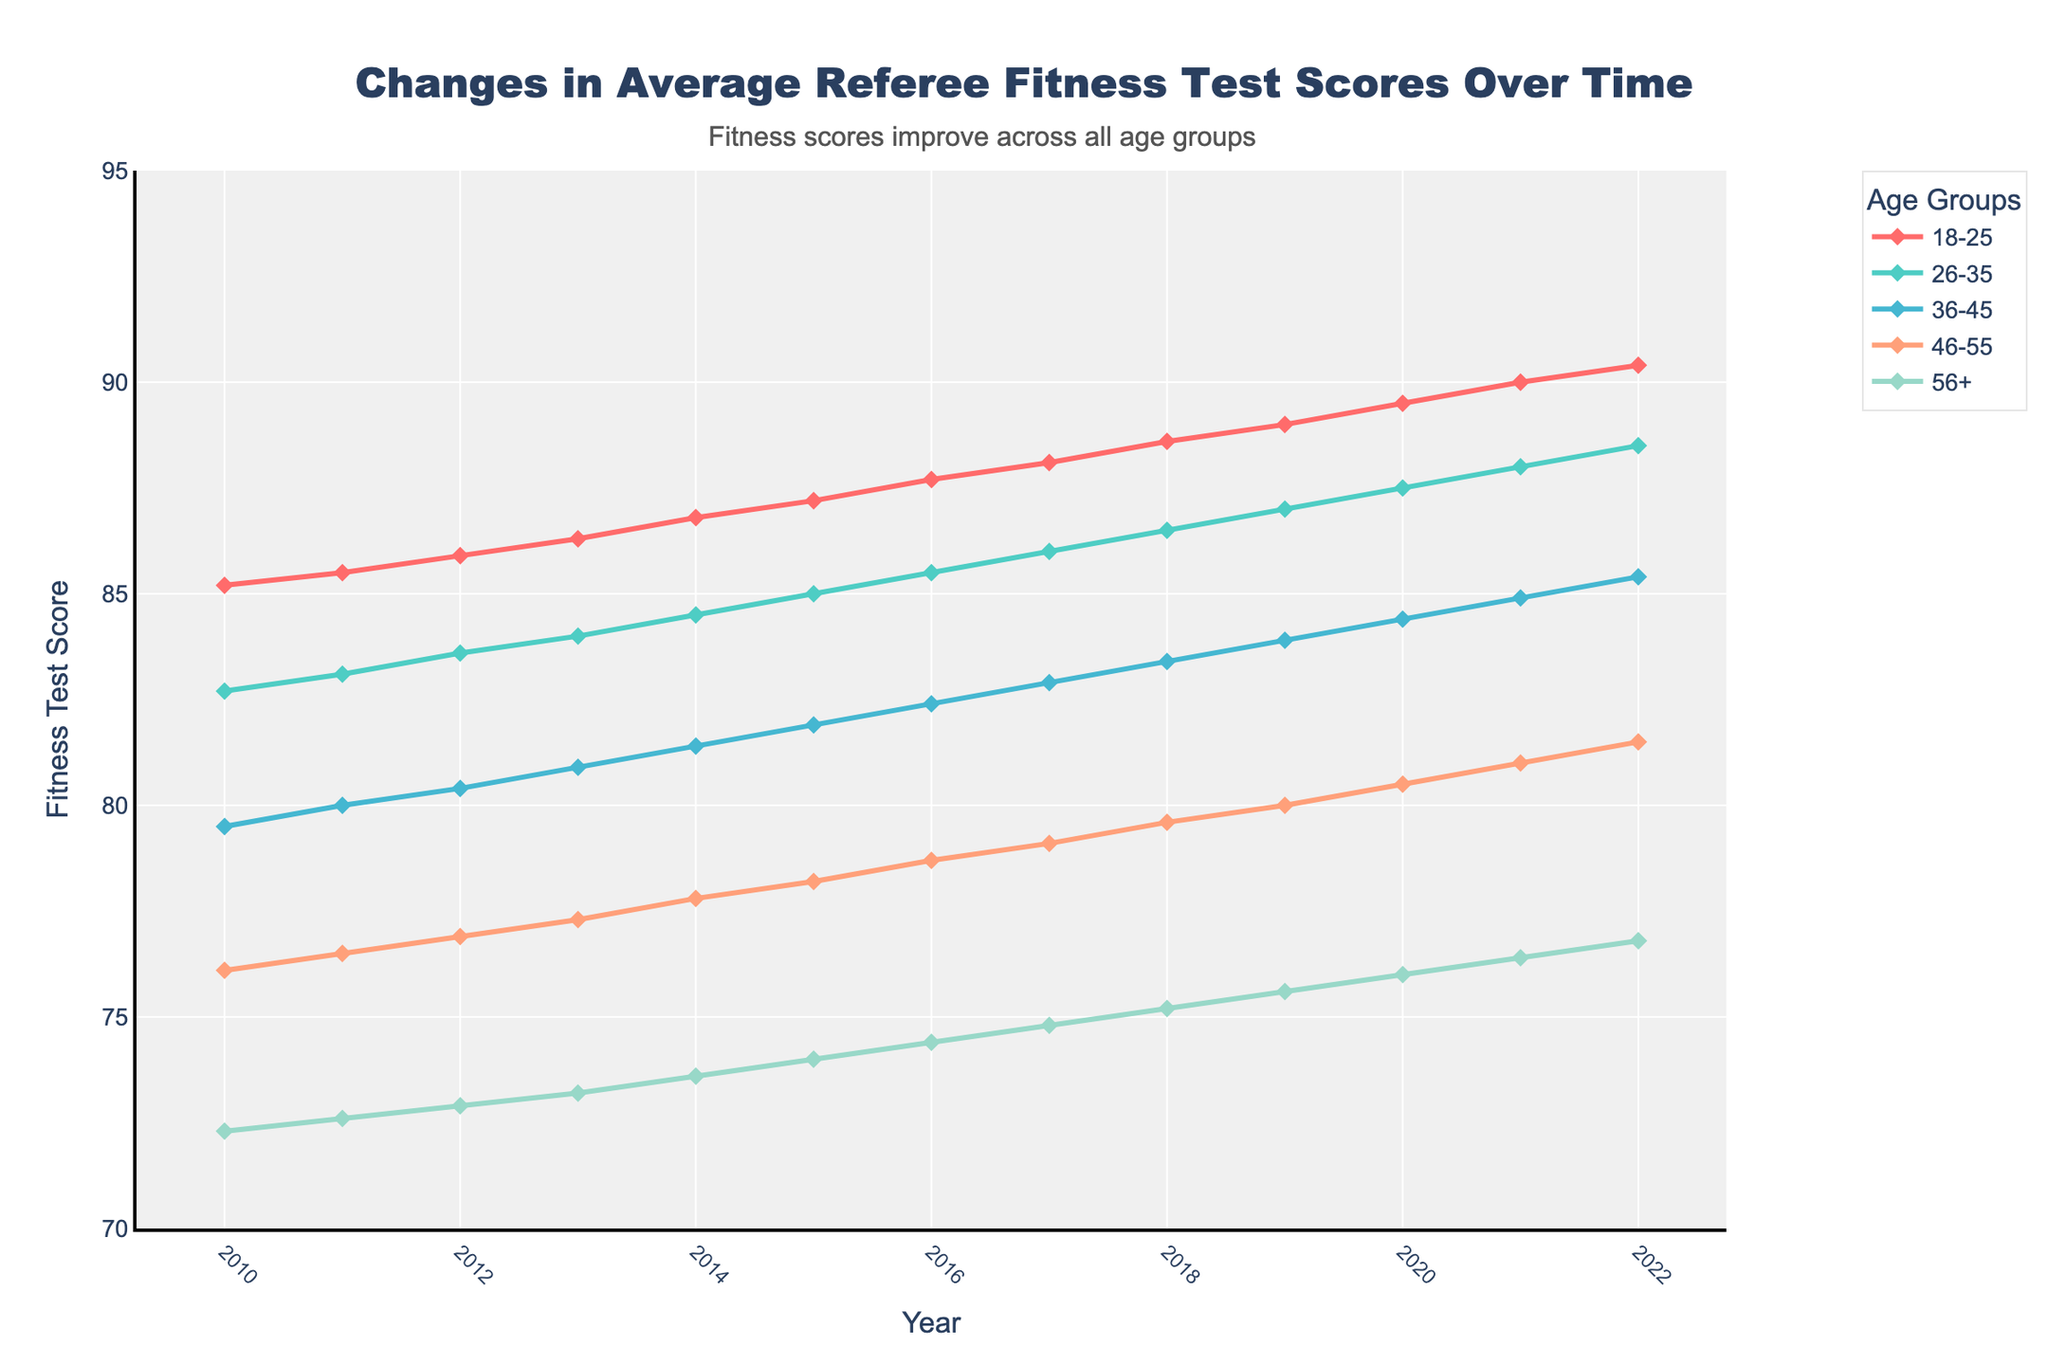What is the general trend in fitness test scores for referees aged 46-55 over the years? The figure shows that the fitness test scores for referees aged 46-55 have increased from 76.1 in 2010 to 81.5 in 2022. Observing the longitudinal data, the score for this age group rises almost every year. This indicates a consistent upward trend.
Answer: Upward trend Which age group had the least improvement in their average fitness test scores from 2010 to 2022? By comparing the 2010 and 2022 scores for each age group, we see the improvements are: 18-25 (+5.2), 26-35 (+5.8), 36-45 (+5.9), 46-55 (+5.4), and 56+ (+4.5). The 56+ group showed the smallest increase, improving from 72.3 in 2010 to 76.8 in 2022.
Answer: 56+ In which year did the 18-25 age group surpass the 90 mark in their average fitness test scores? From the figure, the 18-25 age group scored 89.5 in 2020 and 90.0 in 2021. Therefore, 2021 is the year they first surpassed the 90 mark.
Answer: 2021 How do the fitness test scores for the 26-35 age group in 2014 compare to those in 2017? The figure indicates that the 26-35 age group had a score of 84.5 in 2014 and increased to 86.0 in 2017. Therefore, the score improved by 1.5 points over this period.
Answer: Improved by 1.5 points Which age group consistently had the lowest fitness test scores from 2010 to 2022? By visually comparing the scores across all years, the 56+ age group has the lowest scores in all the years. This trend remains unchanged throughout the period.
Answer: 56+ What's the average change in fitness test scores for the 36-45 age group per year from 2010 to 2022? For the 36-45 age group, their scores improved from 79.5 in 2010 to 85.4 in 2022. The total change is 85.4 - 79.5 = 5.9 over 12 years. The average change per year is 5.9 / 12 ≈ 0.49.
Answer: Approximately 0.49 per year Which age group showed the most significant improvement between any two consecutive years, and what was the change? Observing the figure, the largest single-year improvement is seen in the 18-25 group from 2021 to 2022. They improved from 90.0 to 90.4, which is an increase of 0.4 points. However, although the generality of the short-term improvement is the same, another larger improvement over a longer period should also be considered.
Answer: 18-25 with a change of 0.4 points 